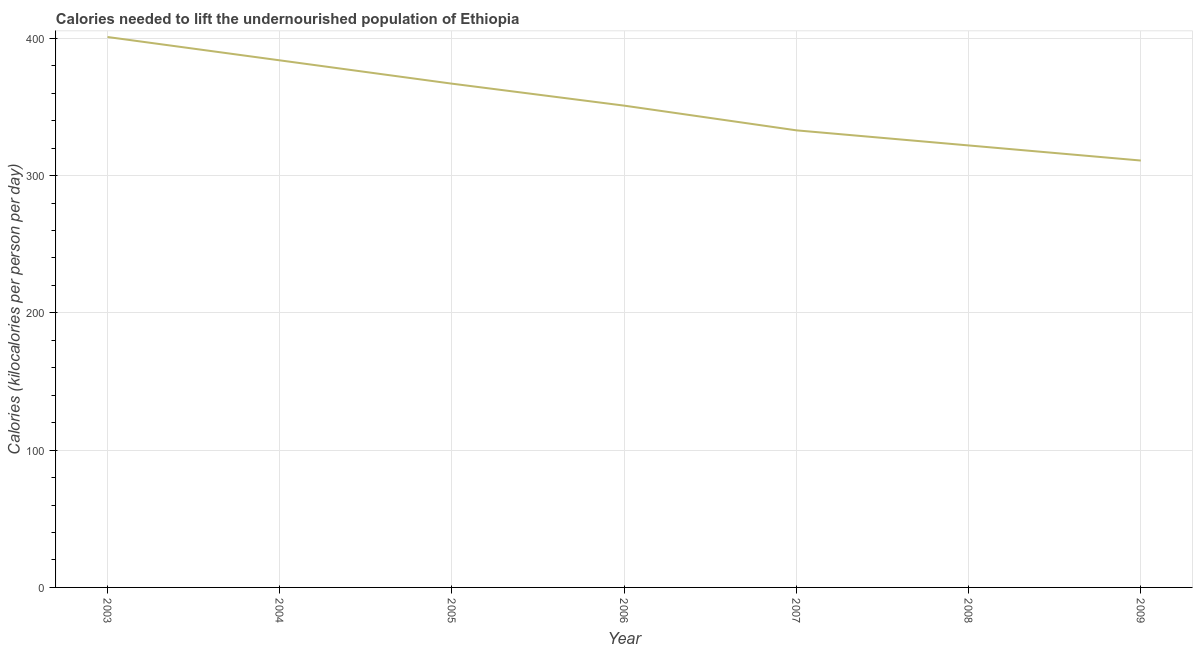What is the depth of food deficit in 2003?
Provide a succinct answer. 401. Across all years, what is the maximum depth of food deficit?
Your answer should be very brief. 401. Across all years, what is the minimum depth of food deficit?
Your answer should be very brief. 311. In which year was the depth of food deficit maximum?
Keep it short and to the point. 2003. What is the sum of the depth of food deficit?
Your answer should be compact. 2469. What is the difference between the depth of food deficit in 2004 and 2007?
Your answer should be very brief. 51. What is the average depth of food deficit per year?
Provide a short and direct response. 352.71. What is the median depth of food deficit?
Offer a terse response. 351. What is the ratio of the depth of food deficit in 2003 to that in 2008?
Your response must be concise. 1.25. Is the depth of food deficit in 2005 less than that in 2009?
Your response must be concise. No. Is the difference between the depth of food deficit in 2006 and 2007 greater than the difference between any two years?
Give a very brief answer. No. What is the difference between the highest and the lowest depth of food deficit?
Your answer should be compact. 90. In how many years, is the depth of food deficit greater than the average depth of food deficit taken over all years?
Ensure brevity in your answer.  3. Does the depth of food deficit monotonically increase over the years?
Provide a short and direct response. No. How many years are there in the graph?
Ensure brevity in your answer.  7. Does the graph contain any zero values?
Give a very brief answer. No. What is the title of the graph?
Make the answer very short. Calories needed to lift the undernourished population of Ethiopia. What is the label or title of the Y-axis?
Make the answer very short. Calories (kilocalories per person per day). What is the Calories (kilocalories per person per day) of 2003?
Make the answer very short. 401. What is the Calories (kilocalories per person per day) in 2004?
Keep it short and to the point. 384. What is the Calories (kilocalories per person per day) of 2005?
Provide a short and direct response. 367. What is the Calories (kilocalories per person per day) of 2006?
Make the answer very short. 351. What is the Calories (kilocalories per person per day) of 2007?
Make the answer very short. 333. What is the Calories (kilocalories per person per day) of 2008?
Provide a short and direct response. 322. What is the Calories (kilocalories per person per day) in 2009?
Your answer should be very brief. 311. What is the difference between the Calories (kilocalories per person per day) in 2003 and 2004?
Offer a very short reply. 17. What is the difference between the Calories (kilocalories per person per day) in 2003 and 2005?
Provide a short and direct response. 34. What is the difference between the Calories (kilocalories per person per day) in 2003 and 2007?
Keep it short and to the point. 68. What is the difference between the Calories (kilocalories per person per day) in 2003 and 2008?
Offer a terse response. 79. What is the difference between the Calories (kilocalories per person per day) in 2004 and 2007?
Your answer should be compact. 51. What is the difference between the Calories (kilocalories per person per day) in 2004 and 2008?
Offer a terse response. 62. What is the difference between the Calories (kilocalories per person per day) in 2005 and 2006?
Keep it short and to the point. 16. What is the difference between the Calories (kilocalories per person per day) in 2005 and 2008?
Ensure brevity in your answer.  45. What is the difference between the Calories (kilocalories per person per day) in 2006 and 2007?
Your answer should be compact. 18. What is the difference between the Calories (kilocalories per person per day) in 2006 and 2008?
Offer a terse response. 29. What is the difference between the Calories (kilocalories per person per day) in 2007 and 2008?
Offer a very short reply. 11. What is the difference between the Calories (kilocalories per person per day) in 2007 and 2009?
Provide a short and direct response. 22. What is the ratio of the Calories (kilocalories per person per day) in 2003 to that in 2004?
Give a very brief answer. 1.04. What is the ratio of the Calories (kilocalories per person per day) in 2003 to that in 2005?
Your answer should be compact. 1.09. What is the ratio of the Calories (kilocalories per person per day) in 2003 to that in 2006?
Ensure brevity in your answer.  1.14. What is the ratio of the Calories (kilocalories per person per day) in 2003 to that in 2007?
Give a very brief answer. 1.2. What is the ratio of the Calories (kilocalories per person per day) in 2003 to that in 2008?
Ensure brevity in your answer.  1.25. What is the ratio of the Calories (kilocalories per person per day) in 2003 to that in 2009?
Make the answer very short. 1.29. What is the ratio of the Calories (kilocalories per person per day) in 2004 to that in 2005?
Make the answer very short. 1.05. What is the ratio of the Calories (kilocalories per person per day) in 2004 to that in 2006?
Your response must be concise. 1.09. What is the ratio of the Calories (kilocalories per person per day) in 2004 to that in 2007?
Your response must be concise. 1.15. What is the ratio of the Calories (kilocalories per person per day) in 2004 to that in 2008?
Give a very brief answer. 1.19. What is the ratio of the Calories (kilocalories per person per day) in 2004 to that in 2009?
Your answer should be compact. 1.24. What is the ratio of the Calories (kilocalories per person per day) in 2005 to that in 2006?
Give a very brief answer. 1.05. What is the ratio of the Calories (kilocalories per person per day) in 2005 to that in 2007?
Provide a short and direct response. 1.1. What is the ratio of the Calories (kilocalories per person per day) in 2005 to that in 2008?
Your answer should be compact. 1.14. What is the ratio of the Calories (kilocalories per person per day) in 2005 to that in 2009?
Make the answer very short. 1.18. What is the ratio of the Calories (kilocalories per person per day) in 2006 to that in 2007?
Provide a succinct answer. 1.05. What is the ratio of the Calories (kilocalories per person per day) in 2006 to that in 2008?
Keep it short and to the point. 1.09. What is the ratio of the Calories (kilocalories per person per day) in 2006 to that in 2009?
Your answer should be compact. 1.13. What is the ratio of the Calories (kilocalories per person per day) in 2007 to that in 2008?
Your answer should be compact. 1.03. What is the ratio of the Calories (kilocalories per person per day) in 2007 to that in 2009?
Your response must be concise. 1.07. What is the ratio of the Calories (kilocalories per person per day) in 2008 to that in 2009?
Keep it short and to the point. 1.03. 